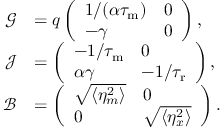Convert formula to latex. <formula><loc_0><loc_0><loc_500><loc_500>\begin{array} { r l } { \mathcal { G } } & { = q \left ( \begin{array} { l l } { 1 / ( \alpha { \tau _ { m } } ) } & { 0 } \\ { - \gamma } & { 0 } \end{array} \right ) , } \\ { \mathcal { J } } & { = \left ( \begin{array} { l l } { - 1 / { \tau _ { m } } } & { 0 } \\ { \alpha \gamma } & { - 1 / { \tau _ { r } } } \end{array} \right ) , } \\ { \mathcal { B } } & { = \left ( \begin{array} { l l } { \sqrt { \langle \eta _ { m } ^ { 2 } \rangle } } & { 0 } \\ { 0 } & { \sqrt { \langle \eta _ { x } ^ { 2 } \rangle } } \end{array} \right ) . } \end{array}</formula> 